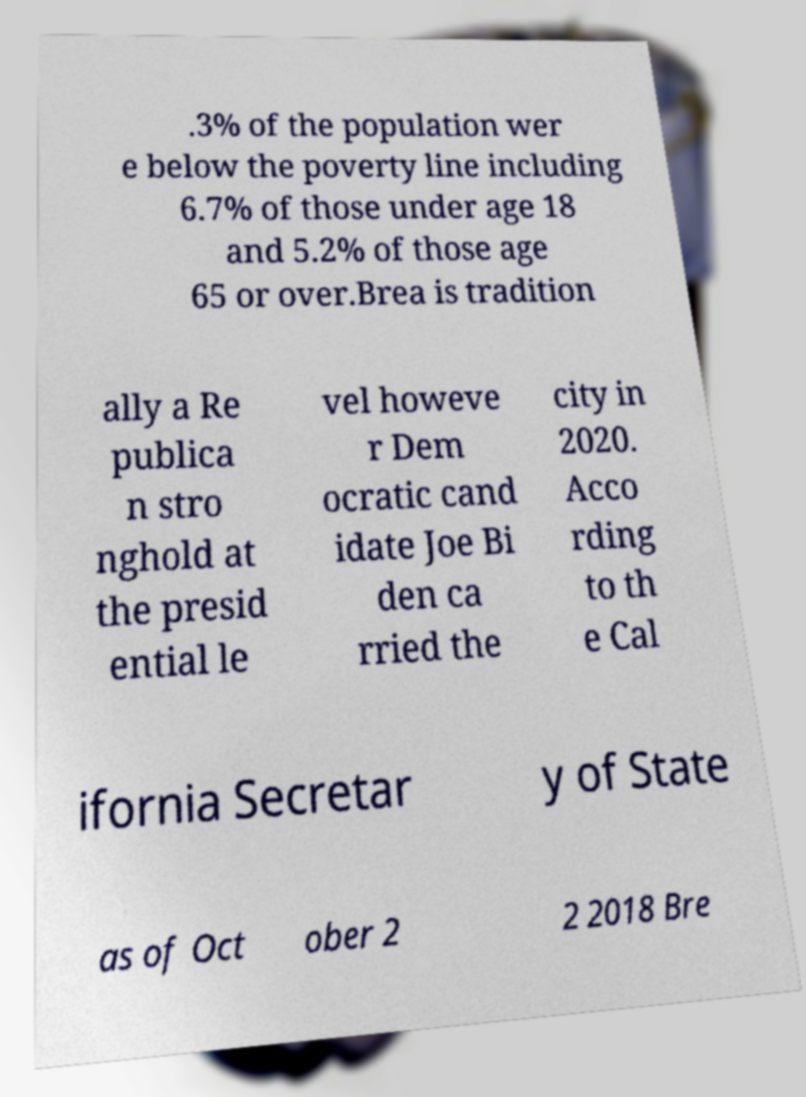Please read and relay the text visible in this image. What does it say? .3% of the population wer e below the poverty line including 6.7% of those under age 18 and 5.2% of those age 65 or over.Brea is tradition ally a Re publica n stro nghold at the presid ential le vel howeve r Dem ocratic cand idate Joe Bi den ca rried the city in 2020. Acco rding to th e Cal ifornia Secretar y of State as of Oct ober 2 2 2018 Bre 